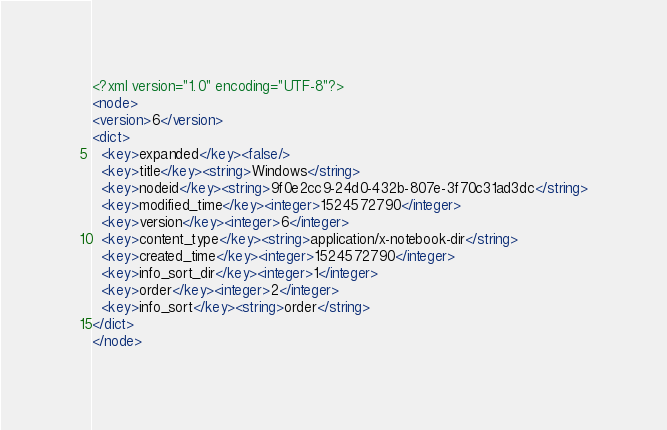Convert code to text. <code><loc_0><loc_0><loc_500><loc_500><_XML_><?xml version="1.0" encoding="UTF-8"?>
<node>
<version>6</version>
<dict>
  <key>expanded</key><false/>
  <key>title</key><string>Windows</string>
  <key>nodeid</key><string>9f0e2cc9-24d0-432b-807e-3f70c31ad3dc</string>
  <key>modified_time</key><integer>1524572790</integer>
  <key>version</key><integer>6</integer>
  <key>content_type</key><string>application/x-notebook-dir</string>
  <key>created_time</key><integer>1524572790</integer>
  <key>info_sort_dir</key><integer>1</integer>
  <key>order</key><integer>2</integer>
  <key>info_sort</key><string>order</string>
</dict>
</node>
</code> 